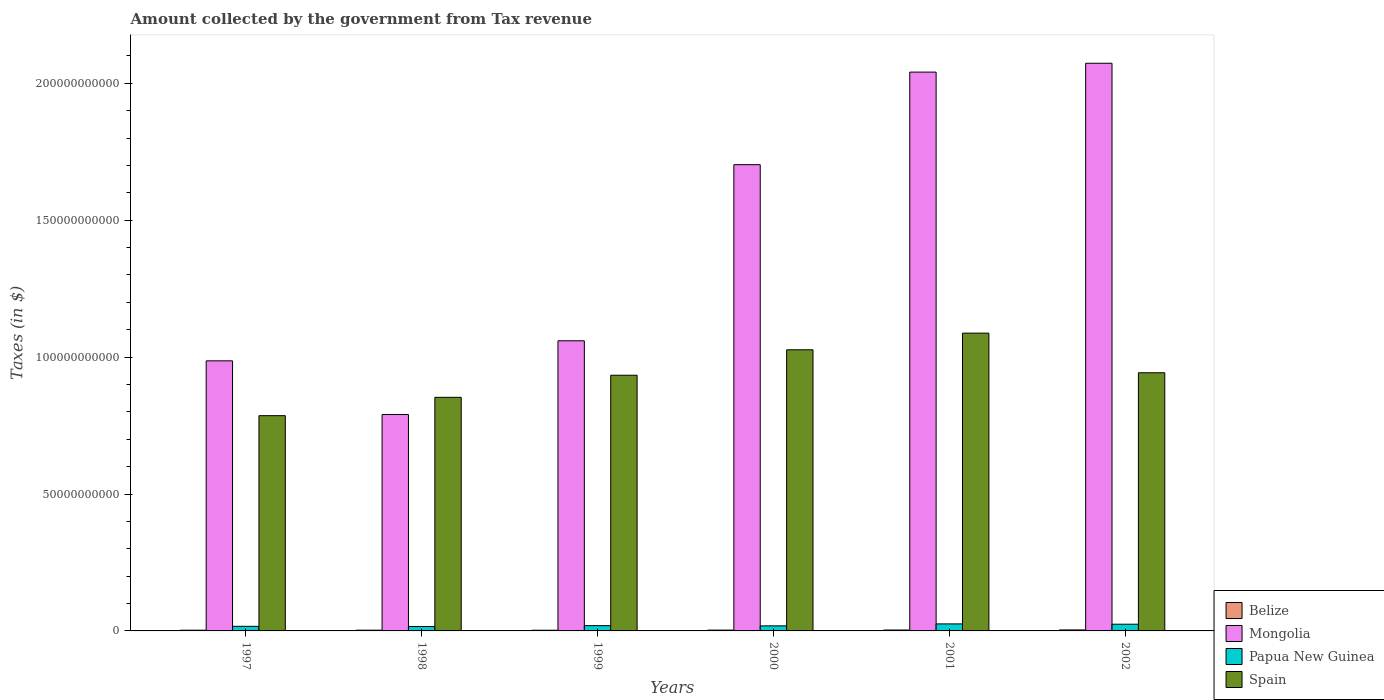How many groups of bars are there?
Offer a terse response. 6. Are the number of bars per tick equal to the number of legend labels?
Give a very brief answer. Yes. Are the number of bars on each tick of the X-axis equal?
Make the answer very short. Yes. How many bars are there on the 2nd tick from the left?
Your answer should be compact. 4. In how many cases, is the number of bars for a given year not equal to the number of legend labels?
Provide a succinct answer. 0. What is the amount collected by the government from tax revenue in Belize in 1997?
Your response must be concise. 2.57e+08. Across all years, what is the maximum amount collected by the government from tax revenue in Spain?
Keep it short and to the point. 1.09e+11. Across all years, what is the minimum amount collected by the government from tax revenue in Papua New Guinea?
Make the answer very short. 1.60e+09. In which year was the amount collected by the government from tax revenue in Spain minimum?
Make the answer very short. 1997. What is the total amount collected by the government from tax revenue in Spain in the graph?
Ensure brevity in your answer.  5.63e+11. What is the difference between the amount collected by the government from tax revenue in Mongolia in 2001 and that in 2002?
Keep it short and to the point. -3.23e+09. What is the difference between the amount collected by the government from tax revenue in Papua New Guinea in 2000 and the amount collected by the government from tax revenue in Spain in 2002?
Ensure brevity in your answer.  -9.24e+1. What is the average amount collected by the government from tax revenue in Belize per year?
Offer a very short reply. 2.94e+08. In the year 1997, what is the difference between the amount collected by the government from tax revenue in Belize and amount collected by the government from tax revenue in Mongolia?
Offer a very short reply. -9.84e+1. In how many years, is the amount collected by the government from tax revenue in Spain greater than 90000000000 $?
Provide a short and direct response. 4. What is the ratio of the amount collected by the government from tax revenue in Mongolia in 1997 to that in 1999?
Offer a very short reply. 0.93. What is the difference between the highest and the second highest amount collected by the government from tax revenue in Papua New Guinea?
Your response must be concise. 1.18e+08. What is the difference between the highest and the lowest amount collected by the government from tax revenue in Spain?
Provide a succinct answer. 3.01e+1. Is the sum of the amount collected by the government from tax revenue in Spain in 1997 and 1998 greater than the maximum amount collected by the government from tax revenue in Belize across all years?
Provide a short and direct response. Yes. What does the 1st bar from the left in 1999 represents?
Provide a short and direct response. Belize. What does the 4th bar from the right in 2002 represents?
Make the answer very short. Belize. How many years are there in the graph?
Make the answer very short. 6. Does the graph contain grids?
Give a very brief answer. No. Where does the legend appear in the graph?
Offer a very short reply. Bottom right. How are the legend labels stacked?
Your answer should be compact. Vertical. What is the title of the graph?
Your answer should be very brief. Amount collected by the government from Tax revenue. Does "Moldova" appear as one of the legend labels in the graph?
Your answer should be very brief. No. What is the label or title of the X-axis?
Give a very brief answer. Years. What is the label or title of the Y-axis?
Give a very brief answer. Taxes (in $). What is the Taxes (in $) in Belize in 1997?
Make the answer very short. 2.57e+08. What is the Taxes (in $) of Mongolia in 1997?
Your answer should be very brief. 9.86e+1. What is the Taxes (in $) of Papua New Guinea in 1997?
Keep it short and to the point. 1.68e+09. What is the Taxes (in $) of Spain in 1997?
Provide a succinct answer. 7.86e+1. What is the Taxes (in $) of Belize in 1998?
Your answer should be very brief. 2.71e+08. What is the Taxes (in $) in Mongolia in 1998?
Give a very brief answer. 7.90e+1. What is the Taxes (in $) of Papua New Guinea in 1998?
Provide a short and direct response. 1.60e+09. What is the Taxes (in $) of Spain in 1998?
Your answer should be very brief. 8.53e+1. What is the Taxes (in $) in Belize in 1999?
Your answer should be very brief. 2.55e+08. What is the Taxes (in $) of Mongolia in 1999?
Offer a terse response. 1.06e+11. What is the Taxes (in $) in Papua New Guinea in 1999?
Your response must be concise. 1.92e+09. What is the Taxes (in $) of Spain in 1999?
Keep it short and to the point. 9.34e+1. What is the Taxes (in $) in Belize in 2000?
Keep it short and to the point. 2.97e+08. What is the Taxes (in $) of Mongolia in 2000?
Your answer should be compact. 1.70e+11. What is the Taxes (in $) in Papua New Guinea in 2000?
Offer a terse response. 1.85e+09. What is the Taxes (in $) of Spain in 2000?
Make the answer very short. 1.03e+11. What is the Taxes (in $) of Belize in 2001?
Ensure brevity in your answer.  3.26e+08. What is the Taxes (in $) of Mongolia in 2001?
Provide a short and direct response. 2.04e+11. What is the Taxes (in $) in Papua New Guinea in 2001?
Provide a succinct answer. 2.57e+09. What is the Taxes (in $) in Spain in 2001?
Your answer should be compact. 1.09e+11. What is the Taxes (in $) in Belize in 2002?
Your answer should be compact. 3.60e+08. What is the Taxes (in $) of Mongolia in 2002?
Offer a very short reply. 2.07e+11. What is the Taxes (in $) in Papua New Guinea in 2002?
Make the answer very short. 2.45e+09. What is the Taxes (in $) in Spain in 2002?
Your answer should be compact. 9.43e+1. Across all years, what is the maximum Taxes (in $) in Belize?
Your answer should be compact. 3.60e+08. Across all years, what is the maximum Taxes (in $) in Mongolia?
Make the answer very short. 2.07e+11. Across all years, what is the maximum Taxes (in $) in Papua New Guinea?
Your answer should be compact. 2.57e+09. Across all years, what is the maximum Taxes (in $) in Spain?
Keep it short and to the point. 1.09e+11. Across all years, what is the minimum Taxes (in $) in Belize?
Ensure brevity in your answer.  2.55e+08. Across all years, what is the minimum Taxes (in $) of Mongolia?
Ensure brevity in your answer.  7.90e+1. Across all years, what is the minimum Taxes (in $) of Papua New Guinea?
Your answer should be compact. 1.60e+09. Across all years, what is the minimum Taxes (in $) of Spain?
Give a very brief answer. 7.86e+1. What is the total Taxes (in $) in Belize in the graph?
Your answer should be compact. 1.77e+09. What is the total Taxes (in $) in Mongolia in the graph?
Offer a terse response. 8.65e+11. What is the total Taxes (in $) in Papua New Guinea in the graph?
Provide a succinct answer. 1.21e+1. What is the total Taxes (in $) of Spain in the graph?
Provide a succinct answer. 5.63e+11. What is the difference between the Taxes (in $) of Belize in 1997 and that in 1998?
Your answer should be compact. -1.42e+07. What is the difference between the Taxes (in $) of Mongolia in 1997 and that in 1998?
Ensure brevity in your answer.  1.96e+1. What is the difference between the Taxes (in $) of Papua New Guinea in 1997 and that in 1998?
Your answer should be compact. 8.13e+07. What is the difference between the Taxes (in $) of Spain in 1997 and that in 1998?
Your answer should be very brief. -6.70e+09. What is the difference between the Taxes (in $) of Belize in 1997 and that in 1999?
Make the answer very short. 2.20e+06. What is the difference between the Taxes (in $) in Mongolia in 1997 and that in 1999?
Your response must be concise. -7.32e+09. What is the difference between the Taxes (in $) in Papua New Guinea in 1997 and that in 1999?
Make the answer very short. -2.44e+08. What is the difference between the Taxes (in $) in Spain in 1997 and that in 1999?
Keep it short and to the point. -1.48e+1. What is the difference between the Taxes (in $) of Belize in 1997 and that in 2000?
Your answer should be compact. -3.95e+07. What is the difference between the Taxes (in $) in Mongolia in 1997 and that in 2000?
Make the answer very short. -7.16e+1. What is the difference between the Taxes (in $) of Papua New Guinea in 1997 and that in 2000?
Provide a succinct answer. -1.68e+08. What is the difference between the Taxes (in $) in Spain in 1997 and that in 2000?
Offer a terse response. -2.41e+1. What is the difference between the Taxes (in $) of Belize in 1997 and that in 2001?
Give a very brief answer. -6.89e+07. What is the difference between the Taxes (in $) of Mongolia in 1997 and that in 2001?
Offer a very short reply. -1.05e+11. What is the difference between the Taxes (in $) in Papua New Guinea in 1997 and that in 2001?
Keep it short and to the point. -8.88e+08. What is the difference between the Taxes (in $) in Spain in 1997 and that in 2001?
Give a very brief answer. -3.01e+1. What is the difference between the Taxes (in $) in Belize in 1997 and that in 2002?
Offer a very short reply. -1.03e+08. What is the difference between the Taxes (in $) of Mongolia in 1997 and that in 2002?
Make the answer very short. -1.09e+11. What is the difference between the Taxes (in $) in Papua New Guinea in 1997 and that in 2002?
Your answer should be compact. -7.70e+08. What is the difference between the Taxes (in $) of Spain in 1997 and that in 2002?
Your response must be concise. -1.57e+1. What is the difference between the Taxes (in $) of Belize in 1998 and that in 1999?
Keep it short and to the point. 1.64e+07. What is the difference between the Taxes (in $) in Mongolia in 1998 and that in 1999?
Make the answer very short. -2.69e+1. What is the difference between the Taxes (in $) of Papua New Guinea in 1998 and that in 1999?
Provide a short and direct response. -3.25e+08. What is the difference between the Taxes (in $) of Spain in 1998 and that in 1999?
Offer a very short reply. -8.08e+09. What is the difference between the Taxes (in $) in Belize in 1998 and that in 2000?
Provide a succinct answer. -2.52e+07. What is the difference between the Taxes (in $) of Mongolia in 1998 and that in 2000?
Ensure brevity in your answer.  -9.12e+1. What is the difference between the Taxes (in $) in Papua New Guinea in 1998 and that in 2000?
Your response must be concise. -2.49e+08. What is the difference between the Taxes (in $) of Spain in 1998 and that in 2000?
Your response must be concise. -1.74e+1. What is the difference between the Taxes (in $) of Belize in 1998 and that in 2001?
Make the answer very short. -5.47e+07. What is the difference between the Taxes (in $) in Mongolia in 1998 and that in 2001?
Keep it short and to the point. -1.25e+11. What is the difference between the Taxes (in $) in Papua New Guinea in 1998 and that in 2001?
Ensure brevity in your answer.  -9.69e+08. What is the difference between the Taxes (in $) in Spain in 1998 and that in 2001?
Provide a succinct answer. -2.34e+1. What is the difference between the Taxes (in $) in Belize in 1998 and that in 2002?
Keep it short and to the point. -8.85e+07. What is the difference between the Taxes (in $) in Mongolia in 1998 and that in 2002?
Provide a succinct answer. -1.28e+11. What is the difference between the Taxes (in $) of Papua New Guinea in 1998 and that in 2002?
Provide a short and direct response. -8.51e+08. What is the difference between the Taxes (in $) of Spain in 1998 and that in 2002?
Offer a very short reply. -8.98e+09. What is the difference between the Taxes (in $) of Belize in 1999 and that in 2000?
Ensure brevity in your answer.  -4.17e+07. What is the difference between the Taxes (in $) of Mongolia in 1999 and that in 2000?
Your answer should be very brief. -6.43e+1. What is the difference between the Taxes (in $) of Papua New Guinea in 1999 and that in 2000?
Give a very brief answer. 7.60e+07. What is the difference between the Taxes (in $) of Spain in 1999 and that in 2000?
Offer a very short reply. -9.29e+09. What is the difference between the Taxes (in $) in Belize in 1999 and that in 2001?
Provide a short and direct response. -7.11e+07. What is the difference between the Taxes (in $) of Mongolia in 1999 and that in 2001?
Your response must be concise. -9.81e+1. What is the difference between the Taxes (in $) of Papua New Guinea in 1999 and that in 2001?
Provide a short and direct response. -6.44e+08. What is the difference between the Taxes (in $) of Spain in 1999 and that in 2001?
Your response must be concise. -1.54e+1. What is the difference between the Taxes (in $) in Belize in 1999 and that in 2002?
Your answer should be compact. -1.05e+08. What is the difference between the Taxes (in $) in Mongolia in 1999 and that in 2002?
Provide a succinct answer. -1.01e+11. What is the difference between the Taxes (in $) in Papua New Guinea in 1999 and that in 2002?
Provide a short and direct response. -5.26e+08. What is the difference between the Taxes (in $) of Spain in 1999 and that in 2002?
Provide a short and direct response. -8.99e+08. What is the difference between the Taxes (in $) of Belize in 2000 and that in 2001?
Ensure brevity in your answer.  -2.94e+07. What is the difference between the Taxes (in $) of Mongolia in 2000 and that in 2001?
Make the answer very short. -3.38e+1. What is the difference between the Taxes (in $) of Papua New Guinea in 2000 and that in 2001?
Your answer should be compact. -7.20e+08. What is the difference between the Taxes (in $) in Spain in 2000 and that in 2001?
Keep it short and to the point. -6.08e+09. What is the difference between the Taxes (in $) of Belize in 2000 and that in 2002?
Offer a very short reply. -6.33e+07. What is the difference between the Taxes (in $) in Mongolia in 2000 and that in 2002?
Offer a terse response. -3.70e+1. What is the difference between the Taxes (in $) in Papua New Guinea in 2000 and that in 2002?
Your answer should be compact. -6.02e+08. What is the difference between the Taxes (in $) in Spain in 2000 and that in 2002?
Provide a succinct answer. 8.39e+09. What is the difference between the Taxes (in $) of Belize in 2001 and that in 2002?
Make the answer very short. -3.38e+07. What is the difference between the Taxes (in $) in Mongolia in 2001 and that in 2002?
Your answer should be very brief. -3.23e+09. What is the difference between the Taxes (in $) of Papua New Guinea in 2001 and that in 2002?
Ensure brevity in your answer.  1.18e+08. What is the difference between the Taxes (in $) in Spain in 2001 and that in 2002?
Keep it short and to the point. 1.45e+1. What is the difference between the Taxes (in $) of Belize in 1997 and the Taxes (in $) of Mongolia in 1998?
Offer a terse response. -7.88e+1. What is the difference between the Taxes (in $) in Belize in 1997 and the Taxes (in $) in Papua New Guinea in 1998?
Offer a very short reply. -1.34e+09. What is the difference between the Taxes (in $) of Belize in 1997 and the Taxes (in $) of Spain in 1998?
Provide a short and direct response. -8.50e+1. What is the difference between the Taxes (in $) of Mongolia in 1997 and the Taxes (in $) of Papua New Guinea in 1998?
Offer a terse response. 9.70e+1. What is the difference between the Taxes (in $) in Mongolia in 1997 and the Taxes (in $) in Spain in 1998?
Give a very brief answer. 1.33e+1. What is the difference between the Taxes (in $) of Papua New Guinea in 1997 and the Taxes (in $) of Spain in 1998?
Provide a short and direct response. -8.36e+1. What is the difference between the Taxes (in $) of Belize in 1997 and the Taxes (in $) of Mongolia in 1999?
Offer a very short reply. -1.06e+11. What is the difference between the Taxes (in $) in Belize in 1997 and the Taxes (in $) in Papua New Guinea in 1999?
Provide a short and direct response. -1.67e+09. What is the difference between the Taxes (in $) of Belize in 1997 and the Taxes (in $) of Spain in 1999?
Your answer should be compact. -9.31e+1. What is the difference between the Taxes (in $) in Mongolia in 1997 and the Taxes (in $) in Papua New Guinea in 1999?
Your response must be concise. 9.67e+1. What is the difference between the Taxes (in $) in Mongolia in 1997 and the Taxes (in $) in Spain in 1999?
Offer a very short reply. 5.26e+09. What is the difference between the Taxes (in $) in Papua New Guinea in 1997 and the Taxes (in $) in Spain in 1999?
Keep it short and to the point. -9.17e+1. What is the difference between the Taxes (in $) of Belize in 1997 and the Taxes (in $) of Mongolia in 2000?
Offer a terse response. -1.70e+11. What is the difference between the Taxes (in $) in Belize in 1997 and the Taxes (in $) in Papua New Guinea in 2000?
Your response must be concise. -1.59e+09. What is the difference between the Taxes (in $) in Belize in 1997 and the Taxes (in $) in Spain in 2000?
Ensure brevity in your answer.  -1.02e+11. What is the difference between the Taxes (in $) of Mongolia in 1997 and the Taxes (in $) of Papua New Guinea in 2000?
Give a very brief answer. 9.68e+1. What is the difference between the Taxes (in $) of Mongolia in 1997 and the Taxes (in $) of Spain in 2000?
Make the answer very short. -4.03e+09. What is the difference between the Taxes (in $) of Papua New Guinea in 1997 and the Taxes (in $) of Spain in 2000?
Ensure brevity in your answer.  -1.01e+11. What is the difference between the Taxes (in $) of Belize in 1997 and the Taxes (in $) of Mongolia in 2001?
Give a very brief answer. -2.04e+11. What is the difference between the Taxes (in $) of Belize in 1997 and the Taxes (in $) of Papua New Guinea in 2001?
Provide a short and direct response. -2.31e+09. What is the difference between the Taxes (in $) of Belize in 1997 and the Taxes (in $) of Spain in 2001?
Make the answer very short. -1.08e+11. What is the difference between the Taxes (in $) of Mongolia in 1997 and the Taxes (in $) of Papua New Guinea in 2001?
Provide a short and direct response. 9.61e+1. What is the difference between the Taxes (in $) of Mongolia in 1997 and the Taxes (in $) of Spain in 2001?
Provide a short and direct response. -1.01e+1. What is the difference between the Taxes (in $) in Papua New Guinea in 1997 and the Taxes (in $) in Spain in 2001?
Offer a terse response. -1.07e+11. What is the difference between the Taxes (in $) in Belize in 1997 and the Taxes (in $) in Mongolia in 2002?
Keep it short and to the point. -2.07e+11. What is the difference between the Taxes (in $) of Belize in 1997 and the Taxes (in $) of Papua New Guinea in 2002?
Provide a short and direct response. -2.19e+09. What is the difference between the Taxes (in $) of Belize in 1997 and the Taxes (in $) of Spain in 2002?
Give a very brief answer. -9.40e+1. What is the difference between the Taxes (in $) in Mongolia in 1997 and the Taxes (in $) in Papua New Guinea in 2002?
Your response must be concise. 9.62e+1. What is the difference between the Taxes (in $) in Mongolia in 1997 and the Taxes (in $) in Spain in 2002?
Your answer should be compact. 4.36e+09. What is the difference between the Taxes (in $) in Papua New Guinea in 1997 and the Taxes (in $) in Spain in 2002?
Your response must be concise. -9.26e+1. What is the difference between the Taxes (in $) of Belize in 1998 and the Taxes (in $) of Mongolia in 1999?
Give a very brief answer. -1.06e+11. What is the difference between the Taxes (in $) in Belize in 1998 and the Taxes (in $) in Papua New Guinea in 1999?
Give a very brief answer. -1.65e+09. What is the difference between the Taxes (in $) in Belize in 1998 and the Taxes (in $) in Spain in 1999?
Give a very brief answer. -9.31e+1. What is the difference between the Taxes (in $) in Mongolia in 1998 and the Taxes (in $) in Papua New Guinea in 1999?
Provide a short and direct response. 7.71e+1. What is the difference between the Taxes (in $) of Mongolia in 1998 and the Taxes (in $) of Spain in 1999?
Your answer should be very brief. -1.44e+1. What is the difference between the Taxes (in $) in Papua New Guinea in 1998 and the Taxes (in $) in Spain in 1999?
Offer a terse response. -9.18e+1. What is the difference between the Taxes (in $) of Belize in 1998 and the Taxes (in $) of Mongolia in 2000?
Ensure brevity in your answer.  -1.70e+11. What is the difference between the Taxes (in $) in Belize in 1998 and the Taxes (in $) in Papua New Guinea in 2000?
Your response must be concise. -1.58e+09. What is the difference between the Taxes (in $) in Belize in 1998 and the Taxes (in $) in Spain in 2000?
Keep it short and to the point. -1.02e+11. What is the difference between the Taxes (in $) in Mongolia in 1998 and the Taxes (in $) in Papua New Guinea in 2000?
Your response must be concise. 7.72e+1. What is the difference between the Taxes (in $) in Mongolia in 1998 and the Taxes (in $) in Spain in 2000?
Offer a very short reply. -2.36e+1. What is the difference between the Taxes (in $) in Papua New Guinea in 1998 and the Taxes (in $) in Spain in 2000?
Offer a terse response. -1.01e+11. What is the difference between the Taxes (in $) in Belize in 1998 and the Taxes (in $) in Mongolia in 2001?
Offer a very short reply. -2.04e+11. What is the difference between the Taxes (in $) of Belize in 1998 and the Taxes (in $) of Papua New Guinea in 2001?
Keep it short and to the point. -2.30e+09. What is the difference between the Taxes (in $) in Belize in 1998 and the Taxes (in $) in Spain in 2001?
Your answer should be compact. -1.08e+11. What is the difference between the Taxes (in $) of Mongolia in 1998 and the Taxes (in $) of Papua New Guinea in 2001?
Offer a very short reply. 7.65e+1. What is the difference between the Taxes (in $) in Mongolia in 1998 and the Taxes (in $) in Spain in 2001?
Ensure brevity in your answer.  -2.97e+1. What is the difference between the Taxes (in $) in Papua New Guinea in 1998 and the Taxes (in $) in Spain in 2001?
Offer a very short reply. -1.07e+11. What is the difference between the Taxes (in $) in Belize in 1998 and the Taxes (in $) in Mongolia in 2002?
Ensure brevity in your answer.  -2.07e+11. What is the difference between the Taxes (in $) of Belize in 1998 and the Taxes (in $) of Papua New Guinea in 2002?
Your answer should be very brief. -2.18e+09. What is the difference between the Taxes (in $) of Belize in 1998 and the Taxes (in $) of Spain in 2002?
Keep it short and to the point. -9.40e+1. What is the difference between the Taxes (in $) in Mongolia in 1998 and the Taxes (in $) in Papua New Guinea in 2002?
Make the answer very short. 7.66e+1. What is the difference between the Taxes (in $) in Mongolia in 1998 and the Taxes (in $) in Spain in 2002?
Your answer should be very brief. -1.52e+1. What is the difference between the Taxes (in $) of Papua New Guinea in 1998 and the Taxes (in $) of Spain in 2002?
Provide a short and direct response. -9.27e+1. What is the difference between the Taxes (in $) of Belize in 1999 and the Taxes (in $) of Mongolia in 2000?
Offer a very short reply. -1.70e+11. What is the difference between the Taxes (in $) of Belize in 1999 and the Taxes (in $) of Papua New Guinea in 2000?
Offer a terse response. -1.59e+09. What is the difference between the Taxes (in $) of Belize in 1999 and the Taxes (in $) of Spain in 2000?
Your answer should be very brief. -1.02e+11. What is the difference between the Taxes (in $) in Mongolia in 1999 and the Taxes (in $) in Papua New Guinea in 2000?
Provide a succinct answer. 1.04e+11. What is the difference between the Taxes (in $) of Mongolia in 1999 and the Taxes (in $) of Spain in 2000?
Ensure brevity in your answer.  3.29e+09. What is the difference between the Taxes (in $) of Papua New Guinea in 1999 and the Taxes (in $) of Spain in 2000?
Keep it short and to the point. -1.01e+11. What is the difference between the Taxes (in $) of Belize in 1999 and the Taxes (in $) of Mongolia in 2001?
Your answer should be very brief. -2.04e+11. What is the difference between the Taxes (in $) in Belize in 1999 and the Taxes (in $) in Papua New Guinea in 2001?
Ensure brevity in your answer.  -2.31e+09. What is the difference between the Taxes (in $) of Belize in 1999 and the Taxes (in $) of Spain in 2001?
Your answer should be very brief. -1.08e+11. What is the difference between the Taxes (in $) of Mongolia in 1999 and the Taxes (in $) of Papua New Guinea in 2001?
Offer a very short reply. 1.03e+11. What is the difference between the Taxes (in $) in Mongolia in 1999 and the Taxes (in $) in Spain in 2001?
Give a very brief answer. -2.80e+09. What is the difference between the Taxes (in $) of Papua New Guinea in 1999 and the Taxes (in $) of Spain in 2001?
Ensure brevity in your answer.  -1.07e+11. What is the difference between the Taxes (in $) in Belize in 1999 and the Taxes (in $) in Mongolia in 2002?
Offer a terse response. -2.07e+11. What is the difference between the Taxes (in $) of Belize in 1999 and the Taxes (in $) of Papua New Guinea in 2002?
Provide a short and direct response. -2.19e+09. What is the difference between the Taxes (in $) of Belize in 1999 and the Taxes (in $) of Spain in 2002?
Your answer should be very brief. -9.40e+1. What is the difference between the Taxes (in $) of Mongolia in 1999 and the Taxes (in $) of Papua New Guinea in 2002?
Your answer should be very brief. 1.04e+11. What is the difference between the Taxes (in $) of Mongolia in 1999 and the Taxes (in $) of Spain in 2002?
Your answer should be very brief. 1.17e+1. What is the difference between the Taxes (in $) of Papua New Guinea in 1999 and the Taxes (in $) of Spain in 2002?
Your response must be concise. -9.24e+1. What is the difference between the Taxes (in $) of Belize in 2000 and the Taxes (in $) of Mongolia in 2001?
Your answer should be compact. -2.04e+11. What is the difference between the Taxes (in $) in Belize in 2000 and the Taxes (in $) in Papua New Guinea in 2001?
Ensure brevity in your answer.  -2.27e+09. What is the difference between the Taxes (in $) in Belize in 2000 and the Taxes (in $) in Spain in 2001?
Keep it short and to the point. -1.08e+11. What is the difference between the Taxes (in $) in Mongolia in 2000 and the Taxes (in $) in Papua New Guinea in 2001?
Provide a short and direct response. 1.68e+11. What is the difference between the Taxes (in $) of Mongolia in 2000 and the Taxes (in $) of Spain in 2001?
Give a very brief answer. 6.15e+1. What is the difference between the Taxes (in $) in Papua New Guinea in 2000 and the Taxes (in $) in Spain in 2001?
Keep it short and to the point. -1.07e+11. What is the difference between the Taxes (in $) in Belize in 2000 and the Taxes (in $) in Mongolia in 2002?
Give a very brief answer. -2.07e+11. What is the difference between the Taxes (in $) in Belize in 2000 and the Taxes (in $) in Papua New Guinea in 2002?
Your answer should be very brief. -2.15e+09. What is the difference between the Taxes (in $) in Belize in 2000 and the Taxes (in $) in Spain in 2002?
Ensure brevity in your answer.  -9.40e+1. What is the difference between the Taxes (in $) of Mongolia in 2000 and the Taxes (in $) of Papua New Guinea in 2002?
Provide a succinct answer. 1.68e+11. What is the difference between the Taxes (in $) in Mongolia in 2000 and the Taxes (in $) in Spain in 2002?
Your answer should be compact. 7.60e+1. What is the difference between the Taxes (in $) in Papua New Guinea in 2000 and the Taxes (in $) in Spain in 2002?
Offer a very short reply. -9.24e+1. What is the difference between the Taxes (in $) of Belize in 2001 and the Taxes (in $) of Mongolia in 2002?
Offer a very short reply. -2.07e+11. What is the difference between the Taxes (in $) of Belize in 2001 and the Taxes (in $) of Papua New Guinea in 2002?
Your answer should be compact. -2.12e+09. What is the difference between the Taxes (in $) in Belize in 2001 and the Taxes (in $) in Spain in 2002?
Offer a terse response. -9.40e+1. What is the difference between the Taxes (in $) of Mongolia in 2001 and the Taxes (in $) of Papua New Guinea in 2002?
Ensure brevity in your answer.  2.02e+11. What is the difference between the Taxes (in $) in Mongolia in 2001 and the Taxes (in $) in Spain in 2002?
Your answer should be compact. 1.10e+11. What is the difference between the Taxes (in $) of Papua New Guinea in 2001 and the Taxes (in $) of Spain in 2002?
Your answer should be very brief. -9.17e+1. What is the average Taxes (in $) in Belize per year?
Keep it short and to the point. 2.94e+08. What is the average Taxes (in $) of Mongolia per year?
Keep it short and to the point. 1.44e+11. What is the average Taxes (in $) in Papua New Guinea per year?
Your answer should be very brief. 2.01e+09. What is the average Taxes (in $) of Spain per year?
Offer a terse response. 9.38e+1. In the year 1997, what is the difference between the Taxes (in $) in Belize and Taxes (in $) in Mongolia?
Ensure brevity in your answer.  -9.84e+1. In the year 1997, what is the difference between the Taxes (in $) in Belize and Taxes (in $) in Papua New Guinea?
Offer a terse response. -1.42e+09. In the year 1997, what is the difference between the Taxes (in $) of Belize and Taxes (in $) of Spain?
Your answer should be compact. -7.83e+1. In the year 1997, what is the difference between the Taxes (in $) in Mongolia and Taxes (in $) in Papua New Guinea?
Your response must be concise. 9.70e+1. In the year 1997, what is the difference between the Taxes (in $) of Mongolia and Taxes (in $) of Spain?
Make the answer very short. 2.00e+1. In the year 1997, what is the difference between the Taxes (in $) in Papua New Guinea and Taxes (in $) in Spain?
Offer a terse response. -7.69e+1. In the year 1998, what is the difference between the Taxes (in $) of Belize and Taxes (in $) of Mongolia?
Offer a very short reply. -7.88e+1. In the year 1998, what is the difference between the Taxes (in $) of Belize and Taxes (in $) of Papua New Guinea?
Offer a terse response. -1.33e+09. In the year 1998, what is the difference between the Taxes (in $) in Belize and Taxes (in $) in Spain?
Make the answer very short. -8.50e+1. In the year 1998, what is the difference between the Taxes (in $) of Mongolia and Taxes (in $) of Papua New Guinea?
Your response must be concise. 7.74e+1. In the year 1998, what is the difference between the Taxes (in $) of Mongolia and Taxes (in $) of Spain?
Offer a very short reply. -6.27e+09. In the year 1998, what is the difference between the Taxes (in $) in Papua New Guinea and Taxes (in $) in Spain?
Offer a terse response. -8.37e+1. In the year 1999, what is the difference between the Taxes (in $) in Belize and Taxes (in $) in Mongolia?
Provide a succinct answer. -1.06e+11. In the year 1999, what is the difference between the Taxes (in $) of Belize and Taxes (in $) of Papua New Guinea?
Give a very brief answer. -1.67e+09. In the year 1999, what is the difference between the Taxes (in $) in Belize and Taxes (in $) in Spain?
Keep it short and to the point. -9.31e+1. In the year 1999, what is the difference between the Taxes (in $) of Mongolia and Taxes (in $) of Papua New Guinea?
Provide a succinct answer. 1.04e+11. In the year 1999, what is the difference between the Taxes (in $) of Mongolia and Taxes (in $) of Spain?
Your answer should be very brief. 1.26e+1. In the year 1999, what is the difference between the Taxes (in $) of Papua New Guinea and Taxes (in $) of Spain?
Make the answer very short. -9.15e+1. In the year 2000, what is the difference between the Taxes (in $) of Belize and Taxes (in $) of Mongolia?
Give a very brief answer. -1.70e+11. In the year 2000, what is the difference between the Taxes (in $) in Belize and Taxes (in $) in Papua New Guinea?
Keep it short and to the point. -1.55e+09. In the year 2000, what is the difference between the Taxes (in $) in Belize and Taxes (in $) in Spain?
Offer a terse response. -1.02e+11. In the year 2000, what is the difference between the Taxes (in $) in Mongolia and Taxes (in $) in Papua New Guinea?
Make the answer very short. 1.68e+11. In the year 2000, what is the difference between the Taxes (in $) of Mongolia and Taxes (in $) of Spain?
Provide a short and direct response. 6.76e+1. In the year 2000, what is the difference between the Taxes (in $) in Papua New Guinea and Taxes (in $) in Spain?
Your answer should be compact. -1.01e+11. In the year 2001, what is the difference between the Taxes (in $) of Belize and Taxes (in $) of Mongolia?
Give a very brief answer. -2.04e+11. In the year 2001, what is the difference between the Taxes (in $) of Belize and Taxes (in $) of Papua New Guinea?
Offer a terse response. -2.24e+09. In the year 2001, what is the difference between the Taxes (in $) in Belize and Taxes (in $) in Spain?
Offer a very short reply. -1.08e+11. In the year 2001, what is the difference between the Taxes (in $) of Mongolia and Taxes (in $) of Papua New Guinea?
Ensure brevity in your answer.  2.02e+11. In the year 2001, what is the difference between the Taxes (in $) in Mongolia and Taxes (in $) in Spain?
Make the answer very short. 9.53e+1. In the year 2001, what is the difference between the Taxes (in $) in Papua New Guinea and Taxes (in $) in Spain?
Offer a terse response. -1.06e+11. In the year 2002, what is the difference between the Taxes (in $) of Belize and Taxes (in $) of Mongolia?
Make the answer very short. -2.07e+11. In the year 2002, what is the difference between the Taxes (in $) of Belize and Taxes (in $) of Papua New Guinea?
Keep it short and to the point. -2.09e+09. In the year 2002, what is the difference between the Taxes (in $) in Belize and Taxes (in $) in Spain?
Offer a very short reply. -9.39e+1. In the year 2002, what is the difference between the Taxes (in $) of Mongolia and Taxes (in $) of Papua New Guinea?
Make the answer very short. 2.05e+11. In the year 2002, what is the difference between the Taxes (in $) in Mongolia and Taxes (in $) in Spain?
Provide a short and direct response. 1.13e+11. In the year 2002, what is the difference between the Taxes (in $) in Papua New Guinea and Taxes (in $) in Spain?
Offer a very short reply. -9.18e+1. What is the ratio of the Taxes (in $) in Belize in 1997 to that in 1998?
Keep it short and to the point. 0.95. What is the ratio of the Taxes (in $) of Mongolia in 1997 to that in 1998?
Offer a very short reply. 1.25. What is the ratio of the Taxes (in $) in Papua New Guinea in 1997 to that in 1998?
Make the answer very short. 1.05. What is the ratio of the Taxes (in $) of Spain in 1997 to that in 1998?
Offer a very short reply. 0.92. What is the ratio of the Taxes (in $) in Belize in 1997 to that in 1999?
Make the answer very short. 1.01. What is the ratio of the Taxes (in $) of Mongolia in 1997 to that in 1999?
Your answer should be compact. 0.93. What is the ratio of the Taxes (in $) in Papua New Guinea in 1997 to that in 1999?
Keep it short and to the point. 0.87. What is the ratio of the Taxes (in $) of Spain in 1997 to that in 1999?
Ensure brevity in your answer.  0.84. What is the ratio of the Taxes (in $) in Belize in 1997 to that in 2000?
Provide a short and direct response. 0.87. What is the ratio of the Taxes (in $) of Mongolia in 1997 to that in 2000?
Give a very brief answer. 0.58. What is the ratio of the Taxes (in $) of Spain in 1997 to that in 2000?
Make the answer very short. 0.77. What is the ratio of the Taxes (in $) of Belize in 1997 to that in 2001?
Give a very brief answer. 0.79. What is the ratio of the Taxes (in $) in Mongolia in 1997 to that in 2001?
Your response must be concise. 0.48. What is the ratio of the Taxes (in $) in Papua New Guinea in 1997 to that in 2001?
Provide a succinct answer. 0.65. What is the ratio of the Taxes (in $) in Spain in 1997 to that in 2001?
Provide a succinct answer. 0.72. What is the ratio of the Taxes (in $) of Belize in 1997 to that in 2002?
Your answer should be compact. 0.71. What is the ratio of the Taxes (in $) in Mongolia in 1997 to that in 2002?
Provide a succinct answer. 0.48. What is the ratio of the Taxes (in $) of Papua New Guinea in 1997 to that in 2002?
Your response must be concise. 0.69. What is the ratio of the Taxes (in $) in Spain in 1997 to that in 2002?
Offer a very short reply. 0.83. What is the ratio of the Taxes (in $) of Belize in 1998 to that in 1999?
Ensure brevity in your answer.  1.06. What is the ratio of the Taxes (in $) of Mongolia in 1998 to that in 1999?
Give a very brief answer. 0.75. What is the ratio of the Taxes (in $) of Papua New Guinea in 1998 to that in 1999?
Your answer should be compact. 0.83. What is the ratio of the Taxes (in $) in Spain in 1998 to that in 1999?
Your response must be concise. 0.91. What is the ratio of the Taxes (in $) in Belize in 1998 to that in 2000?
Ensure brevity in your answer.  0.91. What is the ratio of the Taxes (in $) in Mongolia in 1998 to that in 2000?
Provide a succinct answer. 0.46. What is the ratio of the Taxes (in $) of Papua New Guinea in 1998 to that in 2000?
Ensure brevity in your answer.  0.87. What is the ratio of the Taxes (in $) in Spain in 1998 to that in 2000?
Your response must be concise. 0.83. What is the ratio of the Taxes (in $) of Belize in 1998 to that in 2001?
Make the answer very short. 0.83. What is the ratio of the Taxes (in $) in Mongolia in 1998 to that in 2001?
Your answer should be compact. 0.39. What is the ratio of the Taxes (in $) of Papua New Guinea in 1998 to that in 2001?
Offer a terse response. 0.62. What is the ratio of the Taxes (in $) of Spain in 1998 to that in 2001?
Provide a short and direct response. 0.78. What is the ratio of the Taxes (in $) in Belize in 1998 to that in 2002?
Offer a very short reply. 0.75. What is the ratio of the Taxes (in $) in Mongolia in 1998 to that in 2002?
Offer a terse response. 0.38. What is the ratio of the Taxes (in $) in Papua New Guinea in 1998 to that in 2002?
Ensure brevity in your answer.  0.65. What is the ratio of the Taxes (in $) in Spain in 1998 to that in 2002?
Ensure brevity in your answer.  0.9. What is the ratio of the Taxes (in $) of Belize in 1999 to that in 2000?
Offer a very short reply. 0.86. What is the ratio of the Taxes (in $) of Mongolia in 1999 to that in 2000?
Make the answer very short. 0.62. What is the ratio of the Taxes (in $) of Papua New Guinea in 1999 to that in 2000?
Offer a very short reply. 1.04. What is the ratio of the Taxes (in $) in Spain in 1999 to that in 2000?
Your answer should be very brief. 0.91. What is the ratio of the Taxes (in $) of Belize in 1999 to that in 2001?
Your answer should be very brief. 0.78. What is the ratio of the Taxes (in $) of Mongolia in 1999 to that in 2001?
Offer a very short reply. 0.52. What is the ratio of the Taxes (in $) of Papua New Guinea in 1999 to that in 2001?
Offer a terse response. 0.75. What is the ratio of the Taxes (in $) in Spain in 1999 to that in 2001?
Make the answer very short. 0.86. What is the ratio of the Taxes (in $) in Belize in 1999 to that in 2002?
Keep it short and to the point. 0.71. What is the ratio of the Taxes (in $) in Mongolia in 1999 to that in 2002?
Your response must be concise. 0.51. What is the ratio of the Taxes (in $) of Papua New Guinea in 1999 to that in 2002?
Your answer should be very brief. 0.79. What is the ratio of the Taxes (in $) in Belize in 2000 to that in 2001?
Your answer should be compact. 0.91. What is the ratio of the Taxes (in $) in Mongolia in 2000 to that in 2001?
Your answer should be compact. 0.83. What is the ratio of the Taxes (in $) of Papua New Guinea in 2000 to that in 2001?
Your answer should be compact. 0.72. What is the ratio of the Taxes (in $) in Spain in 2000 to that in 2001?
Your answer should be very brief. 0.94. What is the ratio of the Taxes (in $) in Belize in 2000 to that in 2002?
Offer a terse response. 0.82. What is the ratio of the Taxes (in $) of Mongolia in 2000 to that in 2002?
Offer a very short reply. 0.82. What is the ratio of the Taxes (in $) of Papua New Guinea in 2000 to that in 2002?
Offer a very short reply. 0.75. What is the ratio of the Taxes (in $) of Spain in 2000 to that in 2002?
Keep it short and to the point. 1.09. What is the ratio of the Taxes (in $) in Belize in 2001 to that in 2002?
Keep it short and to the point. 0.91. What is the ratio of the Taxes (in $) of Mongolia in 2001 to that in 2002?
Make the answer very short. 0.98. What is the ratio of the Taxes (in $) of Papua New Guinea in 2001 to that in 2002?
Make the answer very short. 1.05. What is the ratio of the Taxes (in $) in Spain in 2001 to that in 2002?
Give a very brief answer. 1.15. What is the difference between the highest and the second highest Taxes (in $) of Belize?
Make the answer very short. 3.38e+07. What is the difference between the highest and the second highest Taxes (in $) in Mongolia?
Offer a terse response. 3.23e+09. What is the difference between the highest and the second highest Taxes (in $) of Papua New Guinea?
Provide a succinct answer. 1.18e+08. What is the difference between the highest and the second highest Taxes (in $) in Spain?
Your answer should be very brief. 6.08e+09. What is the difference between the highest and the lowest Taxes (in $) of Belize?
Ensure brevity in your answer.  1.05e+08. What is the difference between the highest and the lowest Taxes (in $) in Mongolia?
Provide a succinct answer. 1.28e+11. What is the difference between the highest and the lowest Taxes (in $) in Papua New Guinea?
Keep it short and to the point. 9.69e+08. What is the difference between the highest and the lowest Taxes (in $) in Spain?
Offer a terse response. 3.01e+1. 